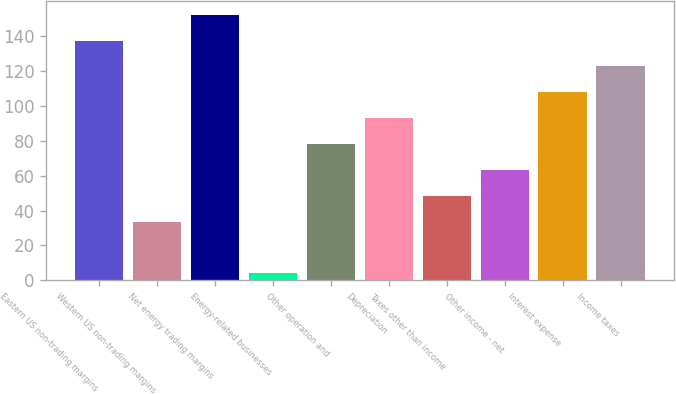Convert chart to OTSL. <chart><loc_0><loc_0><loc_500><loc_500><bar_chart><fcel>Eastern US non-trading margins<fcel>Western US non-trading margins<fcel>Net energy trading margins<fcel>Energy-related businesses<fcel>Other operation and<fcel>Depreciation<fcel>Taxes other than income<fcel>Other income - net<fcel>Interest expense<fcel>Income taxes<nl><fcel>137.2<fcel>33.6<fcel>152<fcel>4<fcel>78<fcel>92.8<fcel>48.4<fcel>63.2<fcel>107.6<fcel>122.4<nl></chart> 